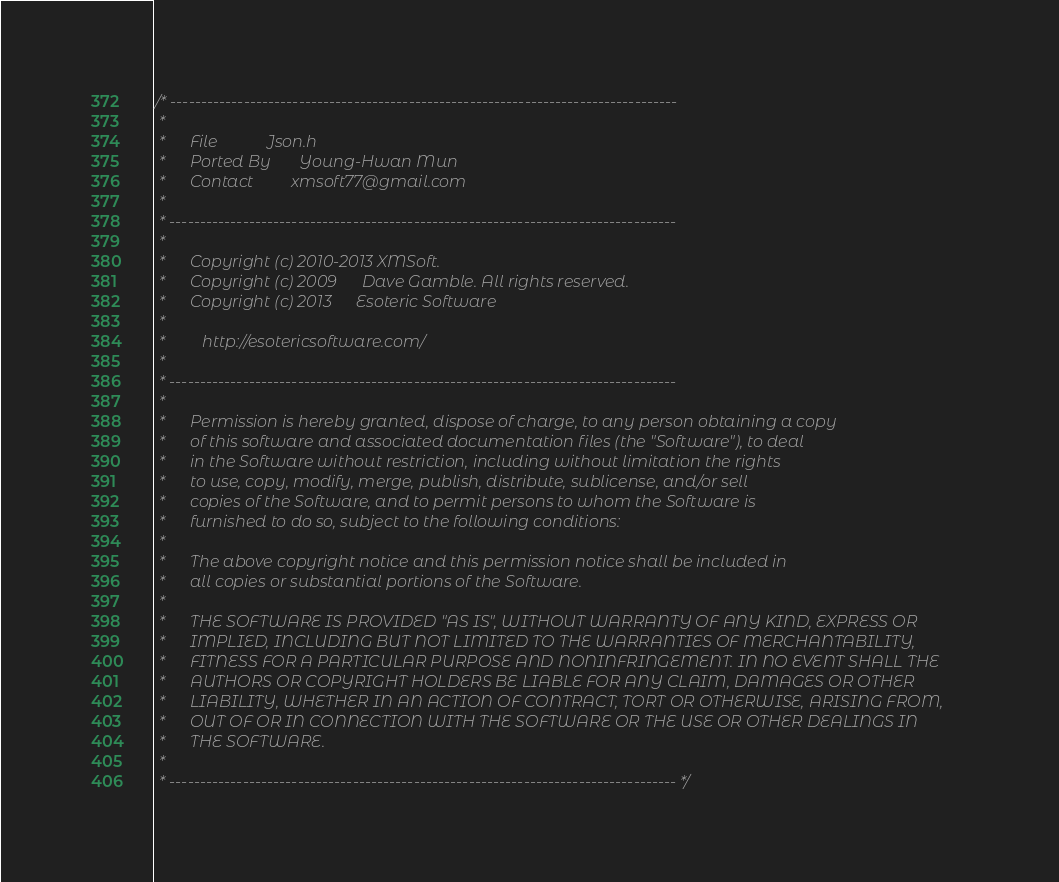Convert code to text. <code><loc_0><loc_0><loc_500><loc_500><_C_>/* -----------------------------------------------------------------------------------
 *
 *      File            Json.h
 *      Ported By       Young-Hwan Mun
 *      Contact         xmsoft77@gmail.com
 * 
 * -----------------------------------------------------------------------------------
 *   
 *      Copyright (c) 2010-2013 XMSoft.
 *      Copyright (c) 2009      Dave Gamble. All rights reserved.
 *      Copyright (c) 2013      Esoteric Software
 *
 *         http://esotericsoftware.com/      
 *
 * -----------------------------------------------------------------------------------
 *  
 *      Permission is hereby granted, dispose of charge, to any person obtaining a copy
 *      of this software and associated documentation files (the "Software"), to deal
 *      in the Software without restriction, including without limitation the rights
 *      to use, copy, modify, merge, publish, distribute, sublicense, and/or sell
 *      copies of the Software, and to permit persons to whom the Software is
 *      furnished to do so, subject to the following conditions:
 *
 *      The above copyright notice and this permission notice shall be included in
 *      all copies or substantial portions of the Software.
 *
 *      THE SOFTWARE IS PROVIDED "AS IS", WITHOUT WARRANTY OF ANY KIND, EXPRESS OR
 *      IMPLIED, INCLUDING BUT NOT LIMITED TO THE WARRANTIES OF MERCHANTABILITY,
 *      FITNESS FOR A PARTICULAR PURPOSE AND NONINFRINGEMENT. IN NO EVENT SHALL THE
 *      AUTHORS OR COPYRIGHT HOLDERS BE LIABLE FOR ANY CLAIM, DAMAGES OR OTHER
 *      LIABILITY, WHETHER IN AN ACTION OF CONTRACT, TORT OR OTHERWISE, ARISING FROM,
 *      OUT OF OR IN CONNECTION WITH THE SOFTWARE OR THE USE OR OTHER DEALINGS IN
 *      THE SOFTWARE.
 *
 * ----------------------------------------------------------------------------------- */ 
</code> 